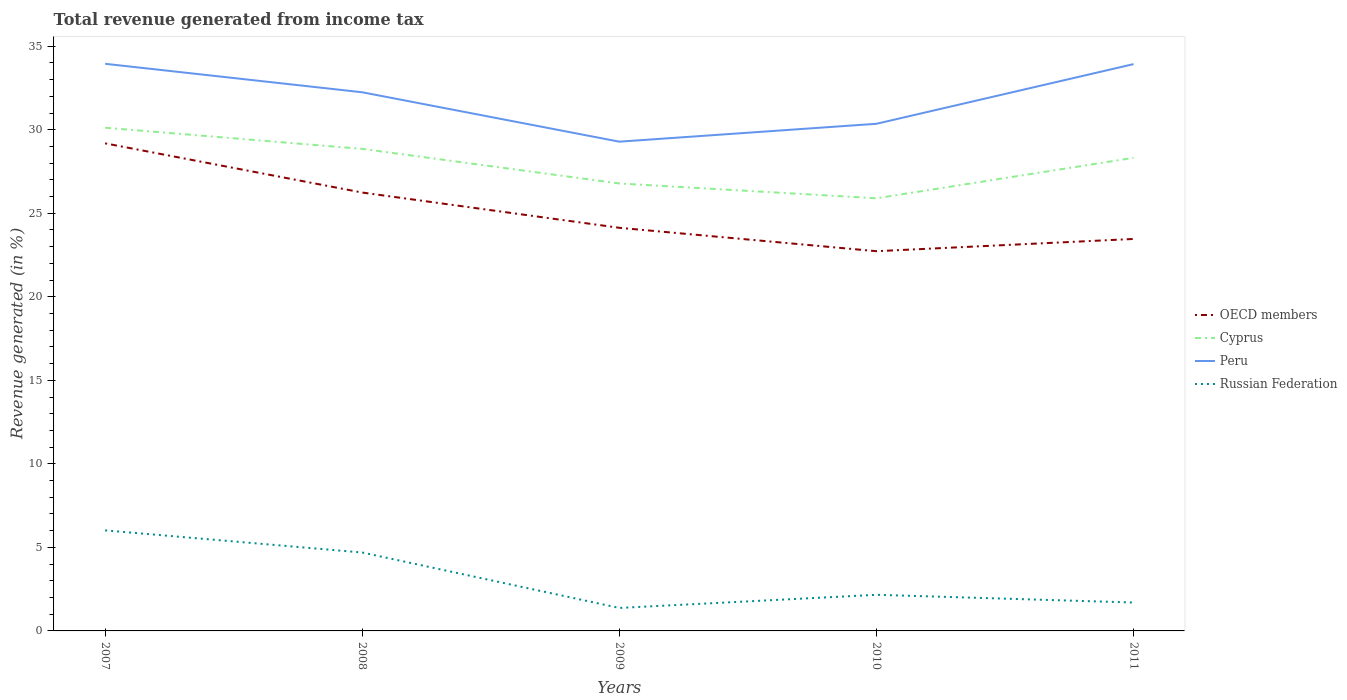How many different coloured lines are there?
Your answer should be very brief. 4. Does the line corresponding to OECD members intersect with the line corresponding to Cyprus?
Provide a short and direct response. No. Is the number of lines equal to the number of legend labels?
Your answer should be very brief. Yes. Across all years, what is the maximum total revenue generated in Cyprus?
Provide a short and direct response. 25.9. What is the total total revenue generated in OECD members in the graph?
Offer a terse response. 5.06. What is the difference between the highest and the second highest total revenue generated in OECD members?
Your answer should be compact. 6.46. What is the difference between the highest and the lowest total revenue generated in Peru?
Provide a short and direct response. 3. Is the total revenue generated in Cyprus strictly greater than the total revenue generated in Russian Federation over the years?
Your response must be concise. No. How many lines are there?
Make the answer very short. 4. How many years are there in the graph?
Offer a terse response. 5. What is the difference between two consecutive major ticks on the Y-axis?
Make the answer very short. 5. Are the values on the major ticks of Y-axis written in scientific E-notation?
Keep it short and to the point. No. Does the graph contain any zero values?
Offer a very short reply. No. How are the legend labels stacked?
Keep it short and to the point. Vertical. What is the title of the graph?
Ensure brevity in your answer.  Total revenue generated from income tax. What is the label or title of the X-axis?
Keep it short and to the point. Years. What is the label or title of the Y-axis?
Keep it short and to the point. Revenue generated (in %). What is the Revenue generated (in %) of OECD members in 2007?
Keep it short and to the point. 29.19. What is the Revenue generated (in %) of Cyprus in 2007?
Your answer should be compact. 30.12. What is the Revenue generated (in %) in Peru in 2007?
Your answer should be compact. 33.95. What is the Revenue generated (in %) in Russian Federation in 2007?
Keep it short and to the point. 6.02. What is the Revenue generated (in %) in OECD members in 2008?
Ensure brevity in your answer.  26.24. What is the Revenue generated (in %) of Cyprus in 2008?
Your answer should be very brief. 28.86. What is the Revenue generated (in %) in Peru in 2008?
Give a very brief answer. 32.24. What is the Revenue generated (in %) of Russian Federation in 2008?
Give a very brief answer. 4.69. What is the Revenue generated (in %) of OECD members in 2009?
Ensure brevity in your answer.  24.13. What is the Revenue generated (in %) in Cyprus in 2009?
Ensure brevity in your answer.  26.78. What is the Revenue generated (in %) in Peru in 2009?
Your answer should be very brief. 29.29. What is the Revenue generated (in %) of Russian Federation in 2009?
Offer a terse response. 1.38. What is the Revenue generated (in %) in OECD members in 2010?
Your answer should be very brief. 22.73. What is the Revenue generated (in %) in Cyprus in 2010?
Provide a succinct answer. 25.9. What is the Revenue generated (in %) of Peru in 2010?
Your answer should be very brief. 30.36. What is the Revenue generated (in %) of Russian Federation in 2010?
Provide a succinct answer. 2.16. What is the Revenue generated (in %) of OECD members in 2011?
Make the answer very short. 23.46. What is the Revenue generated (in %) of Cyprus in 2011?
Keep it short and to the point. 28.32. What is the Revenue generated (in %) in Peru in 2011?
Provide a short and direct response. 33.93. What is the Revenue generated (in %) of Russian Federation in 2011?
Ensure brevity in your answer.  1.7. Across all years, what is the maximum Revenue generated (in %) of OECD members?
Offer a terse response. 29.19. Across all years, what is the maximum Revenue generated (in %) in Cyprus?
Provide a succinct answer. 30.12. Across all years, what is the maximum Revenue generated (in %) of Peru?
Your response must be concise. 33.95. Across all years, what is the maximum Revenue generated (in %) of Russian Federation?
Your answer should be compact. 6.02. Across all years, what is the minimum Revenue generated (in %) of OECD members?
Keep it short and to the point. 22.73. Across all years, what is the minimum Revenue generated (in %) in Cyprus?
Your answer should be very brief. 25.9. Across all years, what is the minimum Revenue generated (in %) of Peru?
Your answer should be very brief. 29.29. Across all years, what is the minimum Revenue generated (in %) in Russian Federation?
Offer a terse response. 1.38. What is the total Revenue generated (in %) in OECD members in the graph?
Your answer should be very brief. 125.75. What is the total Revenue generated (in %) of Cyprus in the graph?
Offer a terse response. 139.98. What is the total Revenue generated (in %) of Peru in the graph?
Make the answer very short. 159.77. What is the total Revenue generated (in %) of Russian Federation in the graph?
Make the answer very short. 15.95. What is the difference between the Revenue generated (in %) in OECD members in 2007 and that in 2008?
Give a very brief answer. 2.94. What is the difference between the Revenue generated (in %) in Cyprus in 2007 and that in 2008?
Your response must be concise. 1.27. What is the difference between the Revenue generated (in %) in Peru in 2007 and that in 2008?
Your answer should be very brief. 1.71. What is the difference between the Revenue generated (in %) in Russian Federation in 2007 and that in 2008?
Make the answer very short. 1.32. What is the difference between the Revenue generated (in %) in OECD members in 2007 and that in 2009?
Keep it short and to the point. 5.06. What is the difference between the Revenue generated (in %) in Cyprus in 2007 and that in 2009?
Your response must be concise. 3.34. What is the difference between the Revenue generated (in %) in Peru in 2007 and that in 2009?
Offer a terse response. 4.66. What is the difference between the Revenue generated (in %) in Russian Federation in 2007 and that in 2009?
Provide a short and direct response. 4.64. What is the difference between the Revenue generated (in %) in OECD members in 2007 and that in 2010?
Keep it short and to the point. 6.46. What is the difference between the Revenue generated (in %) in Cyprus in 2007 and that in 2010?
Keep it short and to the point. 4.22. What is the difference between the Revenue generated (in %) in Peru in 2007 and that in 2010?
Your answer should be very brief. 3.59. What is the difference between the Revenue generated (in %) in Russian Federation in 2007 and that in 2010?
Provide a short and direct response. 3.86. What is the difference between the Revenue generated (in %) of OECD members in 2007 and that in 2011?
Provide a succinct answer. 5.72. What is the difference between the Revenue generated (in %) in Cyprus in 2007 and that in 2011?
Your response must be concise. 1.8. What is the difference between the Revenue generated (in %) in Peru in 2007 and that in 2011?
Make the answer very short. 0.02. What is the difference between the Revenue generated (in %) in Russian Federation in 2007 and that in 2011?
Your response must be concise. 4.32. What is the difference between the Revenue generated (in %) in OECD members in 2008 and that in 2009?
Your answer should be very brief. 2.11. What is the difference between the Revenue generated (in %) in Cyprus in 2008 and that in 2009?
Give a very brief answer. 2.07. What is the difference between the Revenue generated (in %) of Peru in 2008 and that in 2009?
Offer a terse response. 2.96. What is the difference between the Revenue generated (in %) in Russian Federation in 2008 and that in 2009?
Your response must be concise. 3.32. What is the difference between the Revenue generated (in %) in OECD members in 2008 and that in 2010?
Your answer should be compact. 3.51. What is the difference between the Revenue generated (in %) of Cyprus in 2008 and that in 2010?
Your answer should be compact. 2.96. What is the difference between the Revenue generated (in %) in Peru in 2008 and that in 2010?
Provide a succinct answer. 1.89. What is the difference between the Revenue generated (in %) in Russian Federation in 2008 and that in 2010?
Make the answer very short. 2.53. What is the difference between the Revenue generated (in %) in OECD members in 2008 and that in 2011?
Give a very brief answer. 2.78. What is the difference between the Revenue generated (in %) in Cyprus in 2008 and that in 2011?
Provide a short and direct response. 0.54. What is the difference between the Revenue generated (in %) in Peru in 2008 and that in 2011?
Provide a short and direct response. -1.69. What is the difference between the Revenue generated (in %) in Russian Federation in 2008 and that in 2011?
Your answer should be compact. 2.99. What is the difference between the Revenue generated (in %) in OECD members in 2009 and that in 2010?
Keep it short and to the point. 1.4. What is the difference between the Revenue generated (in %) of Cyprus in 2009 and that in 2010?
Your response must be concise. 0.89. What is the difference between the Revenue generated (in %) in Peru in 2009 and that in 2010?
Give a very brief answer. -1.07. What is the difference between the Revenue generated (in %) in Russian Federation in 2009 and that in 2010?
Make the answer very short. -0.79. What is the difference between the Revenue generated (in %) in OECD members in 2009 and that in 2011?
Offer a terse response. 0.67. What is the difference between the Revenue generated (in %) in Cyprus in 2009 and that in 2011?
Provide a short and direct response. -1.54. What is the difference between the Revenue generated (in %) in Peru in 2009 and that in 2011?
Your answer should be very brief. -4.64. What is the difference between the Revenue generated (in %) in Russian Federation in 2009 and that in 2011?
Make the answer very short. -0.33. What is the difference between the Revenue generated (in %) in OECD members in 2010 and that in 2011?
Make the answer very short. -0.73. What is the difference between the Revenue generated (in %) of Cyprus in 2010 and that in 2011?
Your response must be concise. -2.42. What is the difference between the Revenue generated (in %) of Peru in 2010 and that in 2011?
Your answer should be compact. -3.57. What is the difference between the Revenue generated (in %) of Russian Federation in 2010 and that in 2011?
Give a very brief answer. 0.46. What is the difference between the Revenue generated (in %) in OECD members in 2007 and the Revenue generated (in %) in Cyprus in 2008?
Your response must be concise. 0.33. What is the difference between the Revenue generated (in %) of OECD members in 2007 and the Revenue generated (in %) of Peru in 2008?
Ensure brevity in your answer.  -3.06. What is the difference between the Revenue generated (in %) of OECD members in 2007 and the Revenue generated (in %) of Russian Federation in 2008?
Ensure brevity in your answer.  24.49. What is the difference between the Revenue generated (in %) of Cyprus in 2007 and the Revenue generated (in %) of Peru in 2008?
Provide a short and direct response. -2.12. What is the difference between the Revenue generated (in %) in Cyprus in 2007 and the Revenue generated (in %) in Russian Federation in 2008?
Offer a very short reply. 25.43. What is the difference between the Revenue generated (in %) of Peru in 2007 and the Revenue generated (in %) of Russian Federation in 2008?
Offer a very short reply. 29.26. What is the difference between the Revenue generated (in %) in OECD members in 2007 and the Revenue generated (in %) in Cyprus in 2009?
Ensure brevity in your answer.  2.4. What is the difference between the Revenue generated (in %) in OECD members in 2007 and the Revenue generated (in %) in Peru in 2009?
Ensure brevity in your answer.  -0.1. What is the difference between the Revenue generated (in %) of OECD members in 2007 and the Revenue generated (in %) of Russian Federation in 2009?
Provide a succinct answer. 27.81. What is the difference between the Revenue generated (in %) of Cyprus in 2007 and the Revenue generated (in %) of Peru in 2009?
Make the answer very short. 0.83. What is the difference between the Revenue generated (in %) of Cyprus in 2007 and the Revenue generated (in %) of Russian Federation in 2009?
Offer a terse response. 28.75. What is the difference between the Revenue generated (in %) of Peru in 2007 and the Revenue generated (in %) of Russian Federation in 2009?
Offer a very short reply. 32.57. What is the difference between the Revenue generated (in %) of OECD members in 2007 and the Revenue generated (in %) of Cyprus in 2010?
Offer a very short reply. 3.29. What is the difference between the Revenue generated (in %) of OECD members in 2007 and the Revenue generated (in %) of Peru in 2010?
Keep it short and to the point. -1.17. What is the difference between the Revenue generated (in %) of OECD members in 2007 and the Revenue generated (in %) of Russian Federation in 2010?
Offer a terse response. 27.02. What is the difference between the Revenue generated (in %) in Cyprus in 2007 and the Revenue generated (in %) in Peru in 2010?
Offer a terse response. -0.24. What is the difference between the Revenue generated (in %) in Cyprus in 2007 and the Revenue generated (in %) in Russian Federation in 2010?
Offer a very short reply. 27.96. What is the difference between the Revenue generated (in %) of Peru in 2007 and the Revenue generated (in %) of Russian Federation in 2010?
Your answer should be compact. 31.79. What is the difference between the Revenue generated (in %) of OECD members in 2007 and the Revenue generated (in %) of Cyprus in 2011?
Your answer should be compact. 0.87. What is the difference between the Revenue generated (in %) of OECD members in 2007 and the Revenue generated (in %) of Peru in 2011?
Your response must be concise. -4.74. What is the difference between the Revenue generated (in %) in OECD members in 2007 and the Revenue generated (in %) in Russian Federation in 2011?
Give a very brief answer. 27.49. What is the difference between the Revenue generated (in %) in Cyprus in 2007 and the Revenue generated (in %) in Peru in 2011?
Your answer should be very brief. -3.81. What is the difference between the Revenue generated (in %) of Cyprus in 2007 and the Revenue generated (in %) of Russian Federation in 2011?
Your answer should be compact. 28.42. What is the difference between the Revenue generated (in %) of Peru in 2007 and the Revenue generated (in %) of Russian Federation in 2011?
Your answer should be compact. 32.25. What is the difference between the Revenue generated (in %) of OECD members in 2008 and the Revenue generated (in %) of Cyprus in 2009?
Make the answer very short. -0.54. What is the difference between the Revenue generated (in %) in OECD members in 2008 and the Revenue generated (in %) in Peru in 2009?
Make the answer very short. -3.04. What is the difference between the Revenue generated (in %) of OECD members in 2008 and the Revenue generated (in %) of Russian Federation in 2009?
Keep it short and to the point. 24.87. What is the difference between the Revenue generated (in %) of Cyprus in 2008 and the Revenue generated (in %) of Peru in 2009?
Your response must be concise. -0.43. What is the difference between the Revenue generated (in %) in Cyprus in 2008 and the Revenue generated (in %) in Russian Federation in 2009?
Provide a short and direct response. 27.48. What is the difference between the Revenue generated (in %) in Peru in 2008 and the Revenue generated (in %) in Russian Federation in 2009?
Offer a very short reply. 30.87. What is the difference between the Revenue generated (in %) in OECD members in 2008 and the Revenue generated (in %) in Cyprus in 2010?
Provide a short and direct response. 0.34. What is the difference between the Revenue generated (in %) in OECD members in 2008 and the Revenue generated (in %) in Peru in 2010?
Your response must be concise. -4.12. What is the difference between the Revenue generated (in %) in OECD members in 2008 and the Revenue generated (in %) in Russian Federation in 2010?
Provide a succinct answer. 24.08. What is the difference between the Revenue generated (in %) of Cyprus in 2008 and the Revenue generated (in %) of Peru in 2010?
Give a very brief answer. -1.5. What is the difference between the Revenue generated (in %) of Cyprus in 2008 and the Revenue generated (in %) of Russian Federation in 2010?
Provide a succinct answer. 26.69. What is the difference between the Revenue generated (in %) of Peru in 2008 and the Revenue generated (in %) of Russian Federation in 2010?
Give a very brief answer. 30.08. What is the difference between the Revenue generated (in %) in OECD members in 2008 and the Revenue generated (in %) in Cyprus in 2011?
Your response must be concise. -2.08. What is the difference between the Revenue generated (in %) in OECD members in 2008 and the Revenue generated (in %) in Peru in 2011?
Your answer should be very brief. -7.69. What is the difference between the Revenue generated (in %) of OECD members in 2008 and the Revenue generated (in %) of Russian Federation in 2011?
Ensure brevity in your answer.  24.54. What is the difference between the Revenue generated (in %) of Cyprus in 2008 and the Revenue generated (in %) of Peru in 2011?
Give a very brief answer. -5.07. What is the difference between the Revenue generated (in %) in Cyprus in 2008 and the Revenue generated (in %) in Russian Federation in 2011?
Provide a short and direct response. 27.16. What is the difference between the Revenue generated (in %) in Peru in 2008 and the Revenue generated (in %) in Russian Federation in 2011?
Ensure brevity in your answer.  30.54. What is the difference between the Revenue generated (in %) in OECD members in 2009 and the Revenue generated (in %) in Cyprus in 2010?
Your response must be concise. -1.77. What is the difference between the Revenue generated (in %) in OECD members in 2009 and the Revenue generated (in %) in Peru in 2010?
Provide a short and direct response. -6.23. What is the difference between the Revenue generated (in %) of OECD members in 2009 and the Revenue generated (in %) of Russian Federation in 2010?
Keep it short and to the point. 21.97. What is the difference between the Revenue generated (in %) of Cyprus in 2009 and the Revenue generated (in %) of Peru in 2010?
Provide a short and direct response. -3.57. What is the difference between the Revenue generated (in %) of Cyprus in 2009 and the Revenue generated (in %) of Russian Federation in 2010?
Your response must be concise. 24.62. What is the difference between the Revenue generated (in %) of Peru in 2009 and the Revenue generated (in %) of Russian Federation in 2010?
Your answer should be compact. 27.12. What is the difference between the Revenue generated (in %) of OECD members in 2009 and the Revenue generated (in %) of Cyprus in 2011?
Provide a succinct answer. -4.19. What is the difference between the Revenue generated (in %) in OECD members in 2009 and the Revenue generated (in %) in Peru in 2011?
Keep it short and to the point. -9.8. What is the difference between the Revenue generated (in %) of OECD members in 2009 and the Revenue generated (in %) of Russian Federation in 2011?
Keep it short and to the point. 22.43. What is the difference between the Revenue generated (in %) in Cyprus in 2009 and the Revenue generated (in %) in Peru in 2011?
Offer a very short reply. -7.15. What is the difference between the Revenue generated (in %) in Cyprus in 2009 and the Revenue generated (in %) in Russian Federation in 2011?
Your answer should be very brief. 25.08. What is the difference between the Revenue generated (in %) of Peru in 2009 and the Revenue generated (in %) of Russian Federation in 2011?
Your answer should be compact. 27.59. What is the difference between the Revenue generated (in %) in OECD members in 2010 and the Revenue generated (in %) in Cyprus in 2011?
Your answer should be very brief. -5.59. What is the difference between the Revenue generated (in %) in OECD members in 2010 and the Revenue generated (in %) in Peru in 2011?
Offer a very short reply. -11.2. What is the difference between the Revenue generated (in %) in OECD members in 2010 and the Revenue generated (in %) in Russian Federation in 2011?
Give a very brief answer. 21.03. What is the difference between the Revenue generated (in %) in Cyprus in 2010 and the Revenue generated (in %) in Peru in 2011?
Offer a very short reply. -8.03. What is the difference between the Revenue generated (in %) in Cyprus in 2010 and the Revenue generated (in %) in Russian Federation in 2011?
Give a very brief answer. 24.2. What is the difference between the Revenue generated (in %) of Peru in 2010 and the Revenue generated (in %) of Russian Federation in 2011?
Your answer should be compact. 28.66. What is the average Revenue generated (in %) in OECD members per year?
Your answer should be very brief. 25.15. What is the average Revenue generated (in %) in Cyprus per year?
Provide a succinct answer. 28. What is the average Revenue generated (in %) of Peru per year?
Provide a succinct answer. 31.95. What is the average Revenue generated (in %) of Russian Federation per year?
Your answer should be compact. 3.19. In the year 2007, what is the difference between the Revenue generated (in %) in OECD members and Revenue generated (in %) in Cyprus?
Ensure brevity in your answer.  -0.93. In the year 2007, what is the difference between the Revenue generated (in %) in OECD members and Revenue generated (in %) in Peru?
Make the answer very short. -4.76. In the year 2007, what is the difference between the Revenue generated (in %) in OECD members and Revenue generated (in %) in Russian Federation?
Provide a short and direct response. 23.17. In the year 2007, what is the difference between the Revenue generated (in %) of Cyprus and Revenue generated (in %) of Peru?
Ensure brevity in your answer.  -3.83. In the year 2007, what is the difference between the Revenue generated (in %) of Cyprus and Revenue generated (in %) of Russian Federation?
Keep it short and to the point. 24.1. In the year 2007, what is the difference between the Revenue generated (in %) in Peru and Revenue generated (in %) in Russian Federation?
Your answer should be very brief. 27.93. In the year 2008, what is the difference between the Revenue generated (in %) in OECD members and Revenue generated (in %) in Cyprus?
Provide a succinct answer. -2.61. In the year 2008, what is the difference between the Revenue generated (in %) of OECD members and Revenue generated (in %) of Peru?
Your answer should be very brief. -6. In the year 2008, what is the difference between the Revenue generated (in %) of OECD members and Revenue generated (in %) of Russian Federation?
Provide a succinct answer. 21.55. In the year 2008, what is the difference between the Revenue generated (in %) in Cyprus and Revenue generated (in %) in Peru?
Provide a short and direct response. -3.39. In the year 2008, what is the difference between the Revenue generated (in %) of Cyprus and Revenue generated (in %) of Russian Federation?
Offer a terse response. 24.16. In the year 2008, what is the difference between the Revenue generated (in %) in Peru and Revenue generated (in %) in Russian Federation?
Offer a terse response. 27.55. In the year 2009, what is the difference between the Revenue generated (in %) of OECD members and Revenue generated (in %) of Cyprus?
Provide a short and direct response. -2.65. In the year 2009, what is the difference between the Revenue generated (in %) in OECD members and Revenue generated (in %) in Peru?
Your answer should be very brief. -5.16. In the year 2009, what is the difference between the Revenue generated (in %) of OECD members and Revenue generated (in %) of Russian Federation?
Offer a terse response. 22.76. In the year 2009, what is the difference between the Revenue generated (in %) in Cyprus and Revenue generated (in %) in Peru?
Ensure brevity in your answer.  -2.5. In the year 2009, what is the difference between the Revenue generated (in %) of Cyprus and Revenue generated (in %) of Russian Federation?
Provide a succinct answer. 25.41. In the year 2009, what is the difference between the Revenue generated (in %) in Peru and Revenue generated (in %) in Russian Federation?
Offer a terse response. 27.91. In the year 2010, what is the difference between the Revenue generated (in %) in OECD members and Revenue generated (in %) in Cyprus?
Keep it short and to the point. -3.17. In the year 2010, what is the difference between the Revenue generated (in %) in OECD members and Revenue generated (in %) in Peru?
Offer a terse response. -7.63. In the year 2010, what is the difference between the Revenue generated (in %) of OECD members and Revenue generated (in %) of Russian Federation?
Provide a short and direct response. 20.57. In the year 2010, what is the difference between the Revenue generated (in %) of Cyprus and Revenue generated (in %) of Peru?
Provide a succinct answer. -4.46. In the year 2010, what is the difference between the Revenue generated (in %) of Cyprus and Revenue generated (in %) of Russian Federation?
Provide a short and direct response. 23.74. In the year 2010, what is the difference between the Revenue generated (in %) of Peru and Revenue generated (in %) of Russian Federation?
Make the answer very short. 28.2. In the year 2011, what is the difference between the Revenue generated (in %) in OECD members and Revenue generated (in %) in Cyprus?
Ensure brevity in your answer.  -4.86. In the year 2011, what is the difference between the Revenue generated (in %) in OECD members and Revenue generated (in %) in Peru?
Your answer should be compact. -10.47. In the year 2011, what is the difference between the Revenue generated (in %) in OECD members and Revenue generated (in %) in Russian Federation?
Provide a succinct answer. 21.76. In the year 2011, what is the difference between the Revenue generated (in %) of Cyprus and Revenue generated (in %) of Peru?
Give a very brief answer. -5.61. In the year 2011, what is the difference between the Revenue generated (in %) of Cyprus and Revenue generated (in %) of Russian Federation?
Your response must be concise. 26.62. In the year 2011, what is the difference between the Revenue generated (in %) of Peru and Revenue generated (in %) of Russian Federation?
Give a very brief answer. 32.23. What is the ratio of the Revenue generated (in %) of OECD members in 2007 to that in 2008?
Keep it short and to the point. 1.11. What is the ratio of the Revenue generated (in %) of Cyprus in 2007 to that in 2008?
Offer a terse response. 1.04. What is the ratio of the Revenue generated (in %) of Peru in 2007 to that in 2008?
Make the answer very short. 1.05. What is the ratio of the Revenue generated (in %) of Russian Federation in 2007 to that in 2008?
Provide a succinct answer. 1.28. What is the ratio of the Revenue generated (in %) of OECD members in 2007 to that in 2009?
Your answer should be compact. 1.21. What is the ratio of the Revenue generated (in %) of Cyprus in 2007 to that in 2009?
Your answer should be compact. 1.12. What is the ratio of the Revenue generated (in %) in Peru in 2007 to that in 2009?
Provide a succinct answer. 1.16. What is the ratio of the Revenue generated (in %) of Russian Federation in 2007 to that in 2009?
Your answer should be compact. 4.38. What is the ratio of the Revenue generated (in %) in OECD members in 2007 to that in 2010?
Offer a very short reply. 1.28. What is the ratio of the Revenue generated (in %) of Cyprus in 2007 to that in 2010?
Keep it short and to the point. 1.16. What is the ratio of the Revenue generated (in %) of Peru in 2007 to that in 2010?
Your answer should be compact. 1.12. What is the ratio of the Revenue generated (in %) of Russian Federation in 2007 to that in 2010?
Provide a short and direct response. 2.78. What is the ratio of the Revenue generated (in %) in OECD members in 2007 to that in 2011?
Make the answer very short. 1.24. What is the ratio of the Revenue generated (in %) in Cyprus in 2007 to that in 2011?
Your answer should be compact. 1.06. What is the ratio of the Revenue generated (in %) of Russian Federation in 2007 to that in 2011?
Provide a short and direct response. 3.54. What is the ratio of the Revenue generated (in %) in OECD members in 2008 to that in 2009?
Give a very brief answer. 1.09. What is the ratio of the Revenue generated (in %) in Cyprus in 2008 to that in 2009?
Your answer should be compact. 1.08. What is the ratio of the Revenue generated (in %) of Peru in 2008 to that in 2009?
Ensure brevity in your answer.  1.1. What is the ratio of the Revenue generated (in %) in Russian Federation in 2008 to that in 2009?
Ensure brevity in your answer.  3.41. What is the ratio of the Revenue generated (in %) of OECD members in 2008 to that in 2010?
Provide a short and direct response. 1.15. What is the ratio of the Revenue generated (in %) in Cyprus in 2008 to that in 2010?
Keep it short and to the point. 1.11. What is the ratio of the Revenue generated (in %) of Peru in 2008 to that in 2010?
Make the answer very short. 1.06. What is the ratio of the Revenue generated (in %) of Russian Federation in 2008 to that in 2010?
Ensure brevity in your answer.  2.17. What is the ratio of the Revenue generated (in %) in OECD members in 2008 to that in 2011?
Offer a very short reply. 1.12. What is the ratio of the Revenue generated (in %) of Cyprus in 2008 to that in 2011?
Your response must be concise. 1.02. What is the ratio of the Revenue generated (in %) of Peru in 2008 to that in 2011?
Ensure brevity in your answer.  0.95. What is the ratio of the Revenue generated (in %) in Russian Federation in 2008 to that in 2011?
Provide a succinct answer. 2.76. What is the ratio of the Revenue generated (in %) of OECD members in 2009 to that in 2010?
Your response must be concise. 1.06. What is the ratio of the Revenue generated (in %) in Cyprus in 2009 to that in 2010?
Your answer should be very brief. 1.03. What is the ratio of the Revenue generated (in %) of Peru in 2009 to that in 2010?
Your answer should be compact. 0.96. What is the ratio of the Revenue generated (in %) in Russian Federation in 2009 to that in 2010?
Your answer should be very brief. 0.64. What is the ratio of the Revenue generated (in %) of OECD members in 2009 to that in 2011?
Your answer should be very brief. 1.03. What is the ratio of the Revenue generated (in %) in Cyprus in 2009 to that in 2011?
Your answer should be compact. 0.95. What is the ratio of the Revenue generated (in %) of Peru in 2009 to that in 2011?
Offer a very short reply. 0.86. What is the ratio of the Revenue generated (in %) in Russian Federation in 2009 to that in 2011?
Give a very brief answer. 0.81. What is the ratio of the Revenue generated (in %) of OECD members in 2010 to that in 2011?
Keep it short and to the point. 0.97. What is the ratio of the Revenue generated (in %) in Cyprus in 2010 to that in 2011?
Give a very brief answer. 0.91. What is the ratio of the Revenue generated (in %) in Peru in 2010 to that in 2011?
Your response must be concise. 0.89. What is the ratio of the Revenue generated (in %) in Russian Federation in 2010 to that in 2011?
Offer a terse response. 1.27. What is the difference between the highest and the second highest Revenue generated (in %) of OECD members?
Your response must be concise. 2.94. What is the difference between the highest and the second highest Revenue generated (in %) of Cyprus?
Provide a short and direct response. 1.27. What is the difference between the highest and the second highest Revenue generated (in %) of Peru?
Make the answer very short. 0.02. What is the difference between the highest and the second highest Revenue generated (in %) of Russian Federation?
Ensure brevity in your answer.  1.32. What is the difference between the highest and the lowest Revenue generated (in %) of OECD members?
Provide a short and direct response. 6.46. What is the difference between the highest and the lowest Revenue generated (in %) in Cyprus?
Keep it short and to the point. 4.22. What is the difference between the highest and the lowest Revenue generated (in %) of Peru?
Ensure brevity in your answer.  4.66. What is the difference between the highest and the lowest Revenue generated (in %) of Russian Federation?
Offer a terse response. 4.64. 